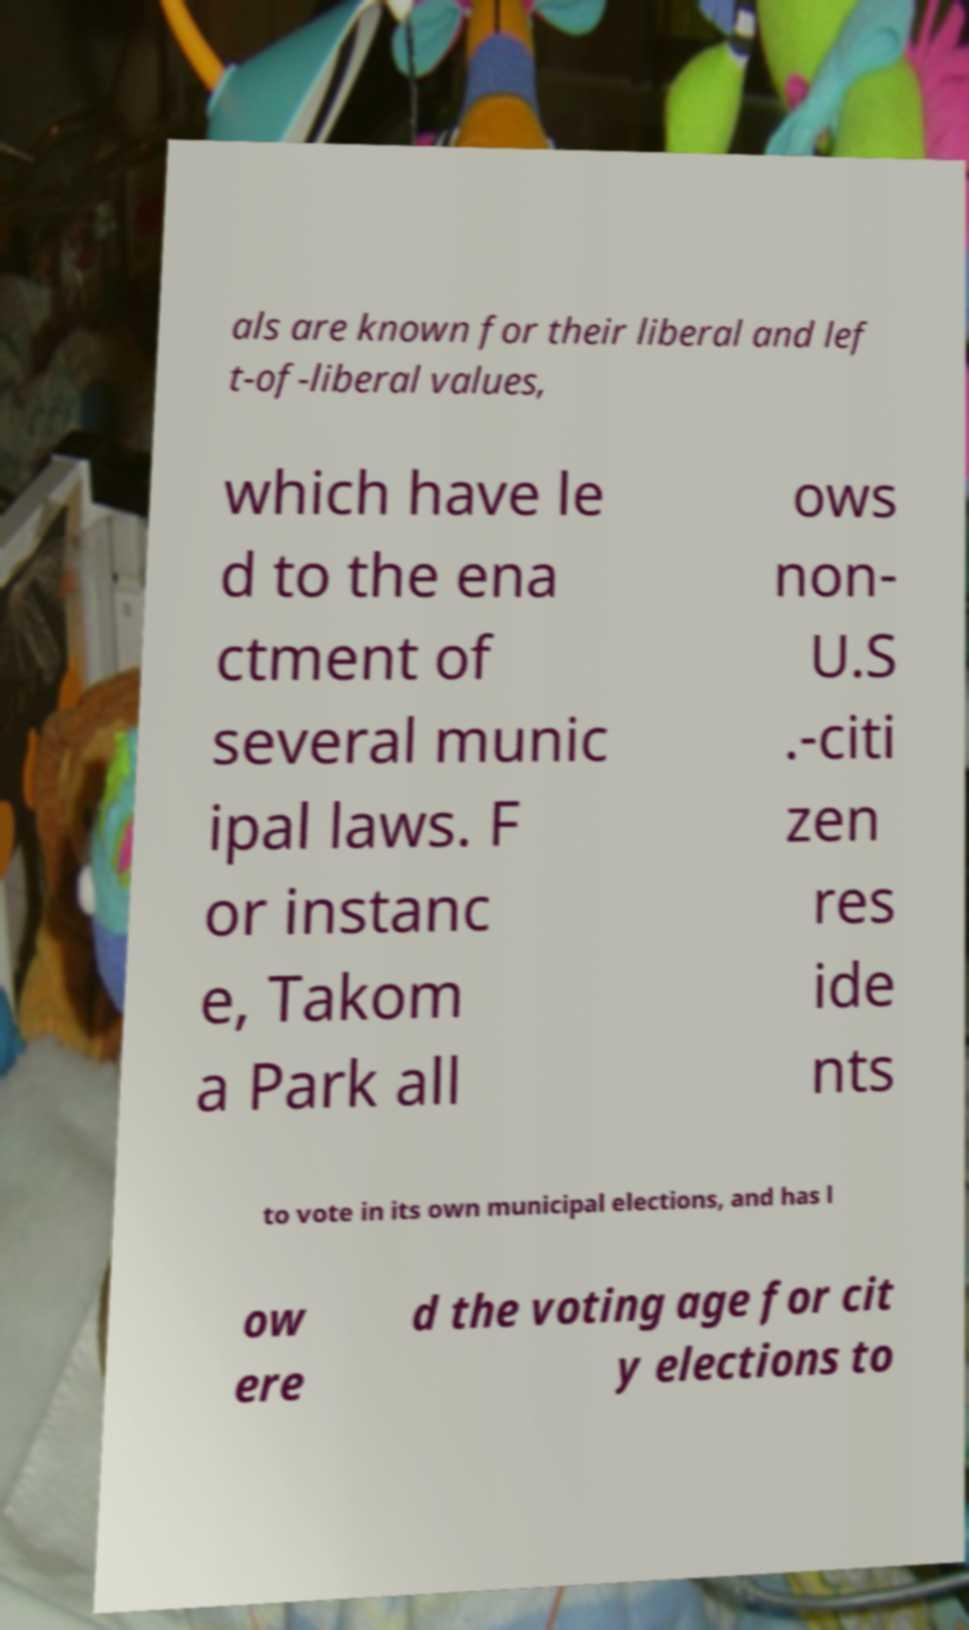For documentation purposes, I need the text within this image transcribed. Could you provide that? als are known for their liberal and lef t-of-liberal values, which have le d to the ena ctment of several munic ipal laws. F or instanc e, Takom a Park all ows non- U.S .-citi zen res ide nts to vote in its own municipal elections, and has l ow ere d the voting age for cit y elections to 